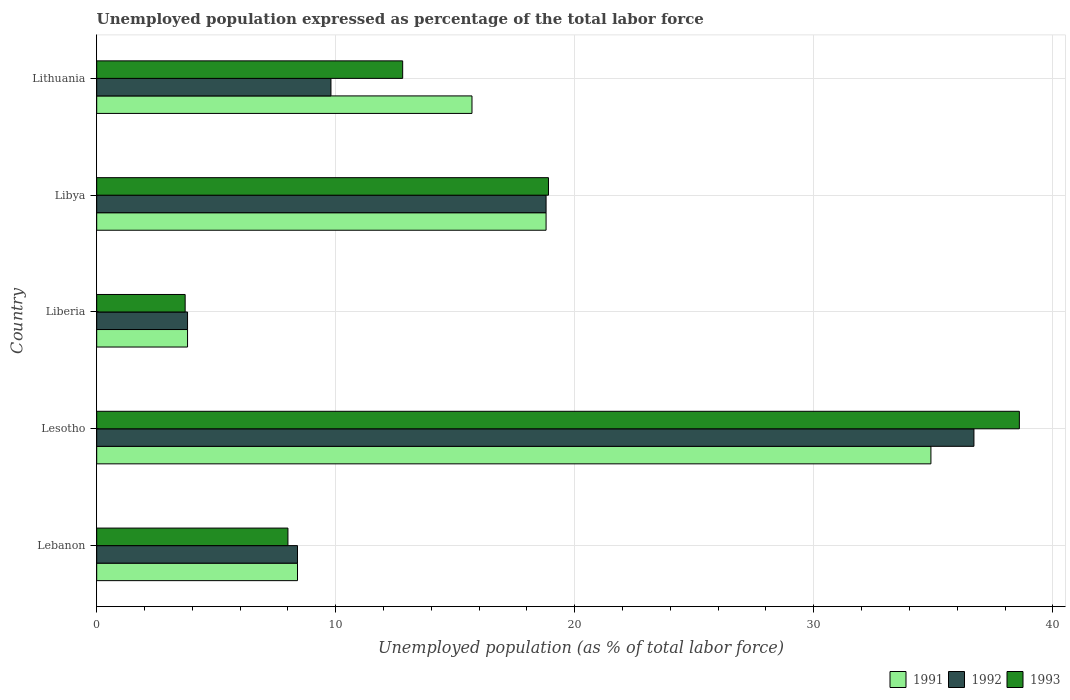How many bars are there on the 3rd tick from the bottom?
Provide a succinct answer. 3. What is the label of the 4th group of bars from the top?
Make the answer very short. Lesotho. In how many cases, is the number of bars for a given country not equal to the number of legend labels?
Provide a succinct answer. 0. What is the unemployment in in 1993 in Lithuania?
Provide a short and direct response. 12.8. Across all countries, what is the maximum unemployment in in 1993?
Offer a very short reply. 38.6. Across all countries, what is the minimum unemployment in in 1992?
Provide a short and direct response. 3.8. In which country was the unemployment in in 1991 maximum?
Keep it short and to the point. Lesotho. In which country was the unemployment in in 1991 minimum?
Your answer should be compact. Liberia. What is the total unemployment in in 1993 in the graph?
Provide a short and direct response. 82. What is the difference between the unemployment in in 1991 in Liberia and that in Libya?
Offer a very short reply. -15. What is the difference between the unemployment in in 1992 in Lebanon and the unemployment in in 1993 in Libya?
Offer a very short reply. -10.5. What is the average unemployment in in 1991 per country?
Provide a short and direct response. 16.32. What is the difference between the unemployment in in 1991 and unemployment in in 1993 in Lebanon?
Offer a terse response. 0.4. In how many countries, is the unemployment in in 1991 greater than 8 %?
Your answer should be compact. 4. What is the ratio of the unemployment in in 1992 in Libya to that in Lithuania?
Your answer should be very brief. 1.92. What is the difference between the highest and the second highest unemployment in in 1991?
Your answer should be very brief. 16.1. What is the difference between the highest and the lowest unemployment in in 1992?
Keep it short and to the point. 32.9. In how many countries, is the unemployment in in 1991 greater than the average unemployment in in 1991 taken over all countries?
Keep it short and to the point. 2. What does the 2nd bar from the bottom in Lebanon represents?
Provide a succinct answer. 1992. How many bars are there?
Offer a terse response. 15. How many countries are there in the graph?
Provide a succinct answer. 5. What is the difference between two consecutive major ticks on the X-axis?
Your answer should be compact. 10. Are the values on the major ticks of X-axis written in scientific E-notation?
Provide a short and direct response. No. Does the graph contain any zero values?
Ensure brevity in your answer.  No. How many legend labels are there?
Offer a very short reply. 3. What is the title of the graph?
Your answer should be very brief. Unemployed population expressed as percentage of the total labor force. What is the label or title of the X-axis?
Offer a terse response. Unemployed population (as % of total labor force). What is the Unemployed population (as % of total labor force) of 1991 in Lebanon?
Offer a terse response. 8.4. What is the Unemployed population (as % of total labor force) of 1992 in Lebanon?
Your answer should be very brief. 8.4. What is the Unemployed population (as % of total labor force) of 1993 in Lebanon?
Make the answer very short. 8. What is the Unemployed population (as % of total labor force) in 1991 in Lesotho?
Ensure brevity in your answer.  34.9. What is the Unemployed population (as % of total labor force) in 1992 in Lesotho?
Make the answer very short. 36.7. What is the Unemployed population (as % of total labor force) in 1993 in Lesotho?
Your answer should be compact. 38.6. What is the Unemployed population (as % of total labor force) of 1991 in Liberia?
Ensure brevity in your answer.  3.8. What is the Unemployed population (as % of total labor force) of 1992 in Liberia?
Offer a terse response. 3.8. What is the Unemployed population (as % of total labor force) in 1993 in Liberia?
Provide a short and direct response. 3.7. What is the Unemployed population (as % of total labor force) of 1991 in Libya?
Offer a terse response. 18.8. What is the Unemployed population (as % of total labor force) of 1992 in Libya?
Provide a succinct answer. 18.8. What is the Unemployed population (as % of total labor force) of 1993 in Libya?
Give a very brief answer. 18.9. What is the Unemployed population (as % of total labor force) in 1991 in Lithuania?
Offer a very short reply. 15.7. What is the Unemployed population (as % of total labor force) of 1992 in Lithuania?
Offer a very short reply. 9.8. What is the Unemployed population (as % of total labor force) of 1993 in Lithuania?
Offer a terse response. 12.8. Across all countries, what is the maximum Unemployed population (as % of total labor force) of 1991?
Ensure brevity in your answer.  34.9. Across all countries, what is the maximum Unemployed population (as % of total labor force) of 1992?
Offer a very short reply. 36.7. Across all countries, what is the maximum Unemployed population (as % of total labor force) in 1993?
Make the answer very short. 38.6. Across all countries, what is the minimum Unemployed population (as % of total labor force) of 1991?
Your answer should be very brief. 3.8. Across all countries, what is the minimum Unemployed population (as % of total labor force) in 1992?
Provide a short and direct response. 3.8. Across all countries, what is the minimum Unemployed population (as % of total labor force) in 1993?
Offer a terse response. 3.7. What is the total Unemployed population (as % of total labor force) of 1991 in the graph?
Offer a very short reply. 81.6. What is the total Unemployed population (as % of total labor force) in 1992 in the graph?
Your answer should be very brief. 77.5. What is the total Unemployed population (as % of total labor force) of 1993 in the graph?
Your answer should be very brief. 82. What is the difference between the Unemployed population (as % of total labor force) of 1991 in Lebanon and that in Lesotho?
Make the answer very short. -26.5. What is the difference between the Unemployed population (as % of total labor force) in 1992 in Lebanon and that in Lesotho?
Provide a succinct answer. -28.3. What is the difference between the Unemployed population (as % of total labor force) in 1993 in Lebanon and that in Lesotho?
Your answer should be compact. -30.6. What is the difference between the Unemployed population (as % of total labor force) of 1991 in Lebanon and that in Liberia?
Provide a short and direct response. 4.6. What is the difference between the Unemployed population (as % of total labor force) in 1992 in Lebanon and that in Liberia?
Your answer should be very brief. 4.6. What is the difference between the Unemployed population (as % of total labor force) of 1993 in Lebanon and that in Liberia?
Provide a short and direct response. 4.3. What is the difference between the Unemployed population (as % of total labor force) in 1991 in Lebanon and that in Libya?
Give a very brief answer. -10.4. What is the difference between the Unemployed population (as % of total labor force) of 1992 in Lebanon and that in Libya?
Your answer should be compact. -10.4. What is the difference between the Unemployed population (as % of total labor force) of 1993 in Lebanon and that in Libya?
Your response must be concise. -10.9. What is the difference between the Unemployed population (as % of total labor force) in 1992 in Lebanon and that in Lithuania?
Your response must be concise. -1.4. What is the difference between the Unemployed population (as % of total labor force) in 1991 in Lesotho and that in Liberia?
Offer a terse response. 31.1. What is the difference between the Unemployed population (as % of total labor force) in 1992 in Lesotho and that in Liberia?
Ensure brevity in your answer.  32.9. What is the difference between the Unemployed population (as % of total labor force) of 1993 in Lesotho and that in Liberia?
Offer a terse response. 34.9. What is the difference between the Unemployed population (as % of total labor force) of 1991 in Lesotho and that in Lithuania?
Keep it short and to the point. 19.2. What is the difference between the Unemployed population (as % of total labor force) in 1992 in Lesotho and that in Lithuania?
Your answer should be very brief. 26.9. What is the difference between the Unemployed population (as % of total labor force) of 1993 in Lesotho and that in Lithuania?
Provide a short and direct response. 25.8. What is the difference between the Unemployed population (as % of total labor force) in 1991 in Liberia and that in Libya?
Your answer should be very brief. -15. What is the difference between the Unemployed population (as % of total labor force) of 1992 in Liberia and that in Libya?
Keep it short and to the point. -15. What is the difference between the Unemployed population (as % of total labor force) in 1993 in Liberia and that in Libya?
Give a very brief answer. -15.2. What is the difference between the Unemployed population (as % of total labor force) of 1991 in Liberia and that in Lithuania?
Your response must be concise. -11.9. What is the difference between the Unemployed population (as % of total labor force) of 1991 in Libya and that in Lithuania?
Keep it short and to the point. 3.1. What is the difference between the Unemployed population (as % of total labor force) of 1991 in Lebanon and the Unemployed population (as % of total labor force) of 1992 in Lesotho?
Provide a short and direct response. -28.3. What is the difference between the Unemployed population (as % of total labor force) in 1991 in Lebanon and the Unemployed population (as % of total labor force) in 1993 in Lesotho?
Give a very brief answer. -30.2. What is the difference between the Unemployed population (as % of total labor force) of 1992 in Lebanon and the Unemployed population (as % of total labor force) of 1993 in Lesotho?
Ensure brevity in your answer.  -30.2. What is the difference between the Unemployed population (as % of total labor force) of 1991 in Lebanon and the Unemployed population (as % of total labor force) of 1992 in Liberia?
Make the answer very short. 4.6. What is the difference between the Unemployed population (as % of total labor force) in 1991 in Lebanon and the Unemployed population (as % of total labor force) in 1993 in Liberia?
Ensure brevity in your answer.  4.7. What is the difference between the Unemployed population (as % of total labor force) of 1992 in Lebanon and the Unemployed population (as % of total labor force) of 1993 in Liberia?
Make the answer very short. 4.7. What is the difference between the Unemployed population (as % of total labor force) of 1991 in Lebanon and the Unemployed population (as % of total labor force) of 1992 in Libya?
Ensure brevity in your answer.  -10.4. What is the difference between the Unemployed population (as % of total labor force) of 1991 in Lebanon and the Unemployed population (as % of total labor force) of 1993 in Libya?
Offer a terse response. -10.5. What is the difference between the Unemployed population (as % of total labor force) of 1992 in Lebanon and the Unemployed population (as % of total labor force) of 1993 in Libya?
Your answer should be compact. -10.5. What is the difference between the Unemployed population (as % of total labor force) in 1991 in Lebanon and the Unemployed population (as % of total labor force) in 1992 in Lithuania?
Offer a very short reply. -1.4. What is the difference between the Unemployed population (as % of total labor force) of 1991 in Lebanon and the Unemployed population (as % of total labor force) of 1993 in Lithuania?
Provide a succinct answer. -4.4. What is the difference between the Unemployed population (as % of total labor force) of 1992 in Lebanon and the Unemployed population (as % of total labor force) of 1993 in Lithuania?
Your response must be concise. -4.4. What is the difference between the Unemployed population (as % of total labor force) of 1991 in Lesotho and the Unemployed population (as % of total labor force) of 1992 in Liberia?
Offer a terse response. 31.1. What is the difference between the Unemployed population (as % of total labor force) of 1991 in Lesotho and the Unemployed population (as % of total labor force) of 1993 in Liberia?
Provide a succinct answer. 31.2. What is the difference between the Unemployed population (as % of total labor force) in 1992 in Lesotho and the Unemployed population (as % of total labor force) in 1993 in Liberia?
Offer a very short reply. 33. What is the difference between the Unemployed population (as % of total labor force) of 1991 in Lesotho and the Unemployed population (as % of total labor force) of 1992 in Libya?
Provide a succinct answer. 16.1. What is the difference between the Unemployed population (as % of total labor force) in 1991 in Lesotho and the Unemployed population (as % of total labor force) in 1993 in Libya?
Provide a succinct answer. 16. What is the difference between the Unemployed population (as % of total labor force) in 1992 in Lesotho and the Unemployed population (as % of total labor force) in 1993 in Libya?
Give a very brief answer. 17.8. What is the difference between the Unemployed population (as % of total labor force) of 1991 in Lesotho and the Unemployed population (as % of total labor force) of 1992 in Lithuania?
Provide a succinct answer. 25.1. What is the difference between the Unemployed population (as % of total labor force) in 1991 in Lesotho and the Unemployed population (as % of total labor force) in 1993 in Lithuania?
Your answer should be compact. 22.1. What is the difference between the Unemployed population (as % of total labor force) of 1992 in Lesotho and the Unemployed population (as % of total labor force) of 1993 in Lithuania?
Offer a very short reply. 23.9. What is the difference between the Unemployed population (as % of total labor force) in 1991 in Liberia and the Unemployed population (as % of total labor force) in 1992 in Libya?
Make the answer very short. -15. What is the difference between the Unemployed population (as % of total labor force) in 1991 in Liberia and the Unemployed population (as % of total labor force) in 1993 in Libya?
Provide a succinct answer. -15.1. What is the difference between the Unemployed population (as % of total labor force) of 1992 in Liberia and the Unemployed population (as % of total labor force) of 1993 in Libya?
Ensure brevity in your answer.  -15.1. What is the difference between the Unemployed population (as % of total labor force) in 1991 in Liberia and the Unemployed population (as % of total labor force) in 1993 in Lithuania?
Your answer should be very brief. -9. What is the difference between the Unemployed population (as % of total labor force) in 1992 in Libya and the Unemployed population (as % of total labor force) in 1993 in Lithuania?
Ensure brevity in your answer.  6. What is the average Unemployed population (as % of total labor force) of 1991 per country?
Keep it short and to the point. 16.32. What is the average Unemployed population (as % of total labor force) in 1992 per country?
Keep it short and to the point. 15.5. What is the difference between the Unemployed population (as % of total labor force) in 1991 and Unemployed population (as % of total labor force) in 1992 in Lebanon?
Your answer should be compact. 0. What is the difference between the Unemployed population (as % of total labor force) of 1991 and Unemployed population (as % of total labor force) of 1993 in Lebanon?
Offer a terse response. 0.4. What is the difference between the Unemployed population (as % of total labor force) in 1991 and Unemployed population (as % of total labor force) in 1992 in Lesotho?
Your answer should be very brief. -1.8. What is the difference between the Unemployed population (as % of total labor force) of 1991 and Unemployed population (as % of total labor force) of 1993 in Lesotho?
Keep it short and to the point. -3.7. What is the difference between the Unemployed population (as % of total labor force) of 1992 and Unemployed population (as % of total labor force) of 1993 in Lesotho?
Provide a succinct answer. -1.9. What is the difference between the Unemployed population (as % of total labor force) of 1991 and Unemployed population (as % of total labor force) of 1993 in Liberia?
Offer a terse response. 0.1. What is the difference between the Unemployed population (as % of total labor force) in 1992 and Unemployed population (as % of total labor force) in 1993 in Liberia?
Provide a succinct answer. 0.1. What is the difference between the Unemployed population (as % of total labor force) in 1991 and Unemployed population (as % of total labor force) in 1992 in Libya?
Give a very brief answer. 0. What is the difference between the Unemployed population (as % of total labor force) in 1991 and Unemployed population (as % of total labor force) in 1993 in Lithuania?
Keep it short and to the point. 2.9. What is the ratio of the Unemployed population (as % of total labor force) in 1991 in Lebanon to that in Lesotho?
Offer a very short reply. 0.24. What is the ratio of the Unemployed population (as % of total labor force) in 1992 in Lebanon to that in Lesotho?
Your answer should be compact. 0.23. What is the ratio of the Unemployed population (as % of total labor force) in 1993 in Lebanon to that in Lesotho?
Your answer should be compact. 0.21. What is the ratio of the Unemployed population (as % of total labor force) in 1991 in Lebanon to that in Liberia?
Your response must be concise. 2.21. What is the ratio of the Unemployed population (as % of total labor force) of 1992 in Lebanon to that in Liberia?
Keep it short and to the point. 2.21. What is the ratio of the Unemployed population (as % of total labor force) of 1993 in Lebanon to that in Liberia?
Offer a terse response. 2.16. What is the ratio of the Unemployed population (as % of total labor force) of 1991 in Lebanon to that in Libya?
Provide a succinct answer. 0.45. What is the ratio of the Unemployed population (as % of total labor force) in 1992 in Lebanon to that in Libya?
Provide a short and direct response. 0.45. What is the ratio of the Unemployed population (as % of total labor force) in 1993 in Lebanon to that in Libya?
Provide a succinct answer. 0.42. What is the ratio of the Unemployed population (as % of total labor force) of 1991 in Lebanon to that in Lithuania?
Provide a short and direct response. 0.54. What is the ratio of the Unemployed population (as % of total labor force) of 1991 in Lesotho to that in Liberia?
Offer a very short reply. 9.18. What is the ratio of the Unemployed population (as % of total labor force) of 1992 in Lesotho to that in Liberia?
Offer a terse response. 9.66. What is the ratio of the Unemployed population (as % of total labor force) of 1993 in Lesotho to that in Liberia?
Ensure brevity in your answer.  10.43. What is the ratio of the Unemployed population (as % of total labor force) of 1991 in Lesotho to that in Libya?
Make the answer very short. 1.86. What is the ratio of the Unemployed population (as % of total labor force) of 1992 in Lesotho to that in Libya?
Make the answer very short. 1.95. What is the ratio of the Unemployed population (as % of total labor force) of 1993 in Lesotho to that in Libya?
Give a very brief answer. 2.04. What is the ratio of the Unemployed population (as % of total labor force) of 1991 in Lesotho to that in Lithuania?
Offer a terse response. 2.22. What is the ratio of the Unemployed population (as % of total labor force) of 1992 in Lesotho to that in Lithuania?
Provide a succinct answer. 3.74. What is the ratio of the Unemployed population (as % of total labor force) in 1993 in Lesotho to that in Lithuania?
Your answer should be compact. 3.02. What is the ratio of the Unemployed population (as % of total labor force) in 1991 in Liberia to that in Libya?
Your response must be concise. 0.2. What is the ratio of the Unemployed population (as % of total labor force) of 1992 in Liberia to that in Libya?
Keep it short and to the point. 0.2. What is the ratio of the Unemployed population (as % of total labor force) of 1993 in Liberia to that in Libya?
Offer a terse response. 0.2. What is the ratio of the Unemployed population (as % of total labor force) in 1991 in Liberia to that in Lithuania?
Keep it short and to the point. 0.24. What is the ratio of the Unemployed population (as % of total labor force) of 1992 in Liberia to that in Lithuania?
Your answer should be very brief. 0.39. What is the ratio of the Unemployed population (as % of total labor force) in 1993 in Liberia to that in Lithuania?
Keep it short and to the point. 0.29. What is the ratio of the Unemployed population (as % of total labor force) of 1991 in Libya to that in Lithuania?
Keep it short and to the point. 1.2. What is the ratio of the Unemployed population (as % of total labor force) of 1992 in Libya to that in Lithuania?
Offer a very short reply. 1.92. What is the ratio of the Unemployed population (as % of total labor force) in 1993 in Libya to that in Lithuania?
Make the answer very short. 1.48. What is the difference between the highest and the second highest Unemployed population (as % of total labor force) of 1991?
Your answer should be compact. 16.1. What is the difference between the highest and the second highest Unemployed population (as % of total labor force) of 1992?
Your response must be concise. 17.9. What is the difference between the highest and the lowest Unemployed population (as % of total labor force) in 1991?
Make the answer very short. 31.1. What is the difference between the highest and the lowest Unemployed population (as % of total labor force) in 1992?
Your answer should be very brief. 32.9. What is the difference between the highest and the lowest Unemployed population (as % of total labor force) of 1993?
Your answer should be compact. 34.9. 